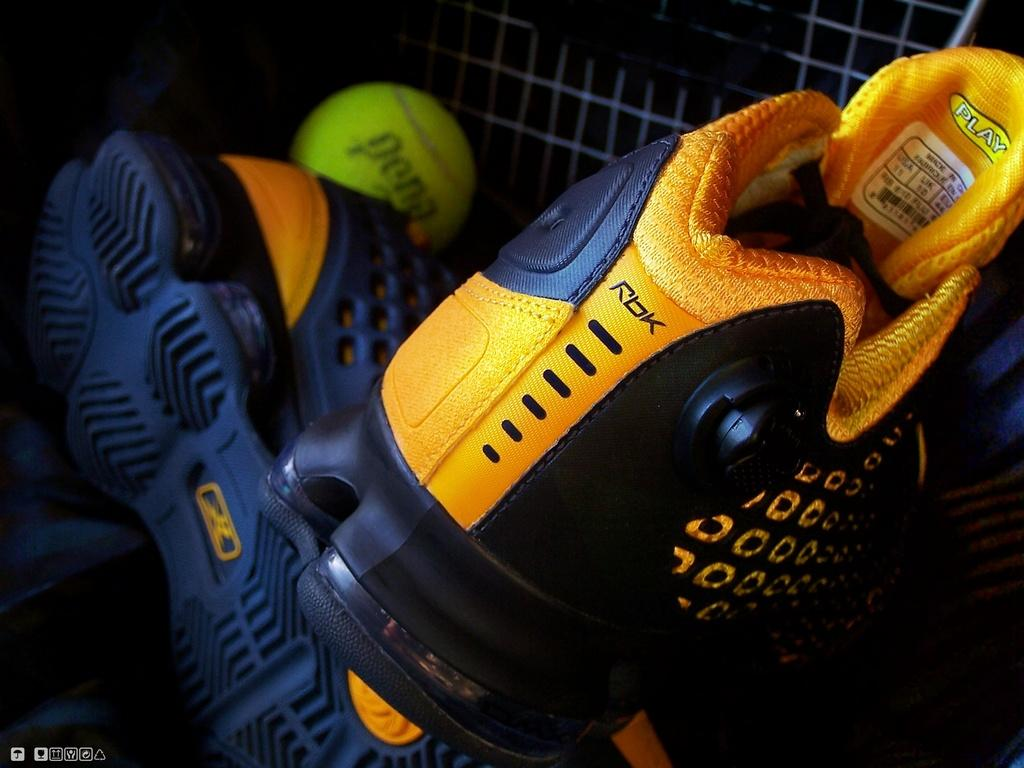What is located in the center of the image? There are shoes and a ball in the center of the image. What type of object is in the center of the image along with the shoes? There is a ball in the center of the image. What can be seen in the background of the image? There is a fence in the background of the image. What type of lace can be seen on the shoes in the image? There is no specific detail about the lace on the shoes in the image, as the focus is on their presence in the center of the image. What type of bubble is visible in the image? There is no bubble present in the image. 